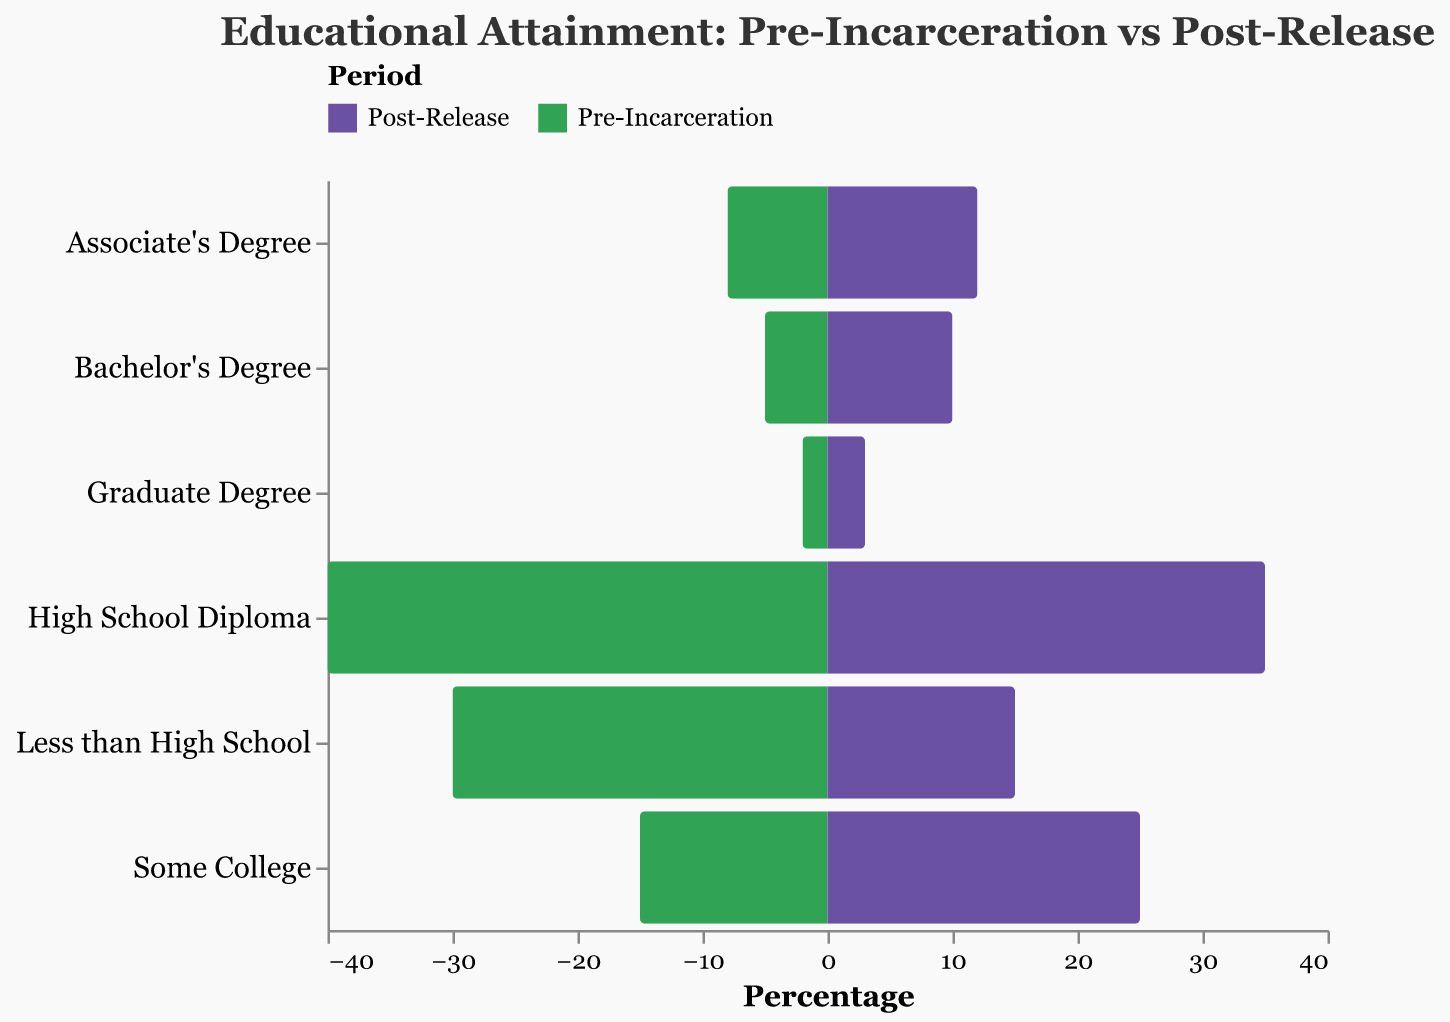What category saw the highest level of educational attainment pre-incarceration? The category with the largest negative bar (Pre-Incarceration) represent highest pre-incarceration level. High School Diploma has the largest bar in the negative direction.
Answer: High School Diploma Which educational category experienced the most significant increase from pre-incarceration to post-release? Compare the difference for each category between the Pre-Incarceration and Post-Release. The most significant increase is seen in Bachelor’s Degree (from 5 to 10).
Answer: Bachelor's Degree What is the difference in the percentage of individuals with less than a high school education pre-incarceration and post-release? Subtract the post-release value from the pre-incarceration value for the category "Less than High School" (30 - 15).
Answer: 15 Which educational level saw a decrease from pre-incarceration to post-release? Identify bars that shrink from Pre-Incarceration to Post-Release. "Less than High School" and "High School Diploma" experienced decreases.
Answer: Less than High School, High School Diploma How does the percentage of individuals with a graduate degree change from pre-incarceration to post-release? Compare the values for graduate degrees: Pre-Incarceration is 2 and Post-Release is 3, indicating an increase.
Answer: Increase What is the total percentage of individuals with some form of college education (including Associate's, Bachelor's and Graduate degrees) post-release? Sum the percentages for "Some College," "Associate's Degree," "Bachelor's Degree," and "Graduate Degree" (25 + 12 + 10 + 3).
Answer: 50 Which category shows the smallest difference between pre-incarceration and post-release values? Calculate the absolute difference for each category and find the smallest one. Graduate Degree has the smallest difference (3 - 2 = 1).
Answer: Graduate Degree How does the high school diploma category's percentage differ between pre-incarceration and post-release? Subtract Post-Release values from Pre-Incarceration values for "High School Diploma" (40 - 35).
Answer: 5 Is there an overall trend of educational attainment levels increasing or decreasing from pre-incarceration to post-release? Most bars show increases from Pre-Incarceration to Post-Release, indicating educational attainment levels generally increase.
Answer: Increasing Which category had a higher percentage post-release compared to pre-incarceration? Look for categories where the positive bar (Post-Release) is larger than the negative bar (Pre-Incarceration). These are "Some College," "Associate's Degree," "Bachelor's Degree," and "Graduate Degree."
Answer: Some College, Associate's Degree, Bachelor's Degree, Graduate Degree 